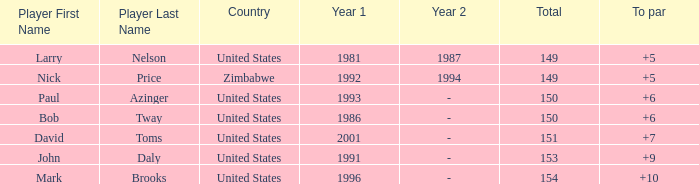Can you give me this table as a dict? {'header': ['Player First Name', 'Player Last Name', 'Country', 'Year 1', 'Year 2', 'Total', 'To par'], 'rows': [['Larry', 'Nelson', 'United States', '1981', '1987', '149', '+5'], ['Nick', 'Price', 'Zimbabwe', '1992', '1994', '149', '+5'], ['Paul', 'Azinger', 'United States', '1993', '-', '150', '+6'], ['Bob', 'Tway', 'United States', '1986', '-', '150', '+6'], ['David', 'Toms', 'United States', '2001', '-', '151', '+7'], ['John', 'Daly', 'United States', '1991', '-', '153', '+9'], ['Mark', 'Brooks', 'United States', '1996', '-', '154', '+10']]} What is Zimbabwe's total with a to par higher than 5? None. 